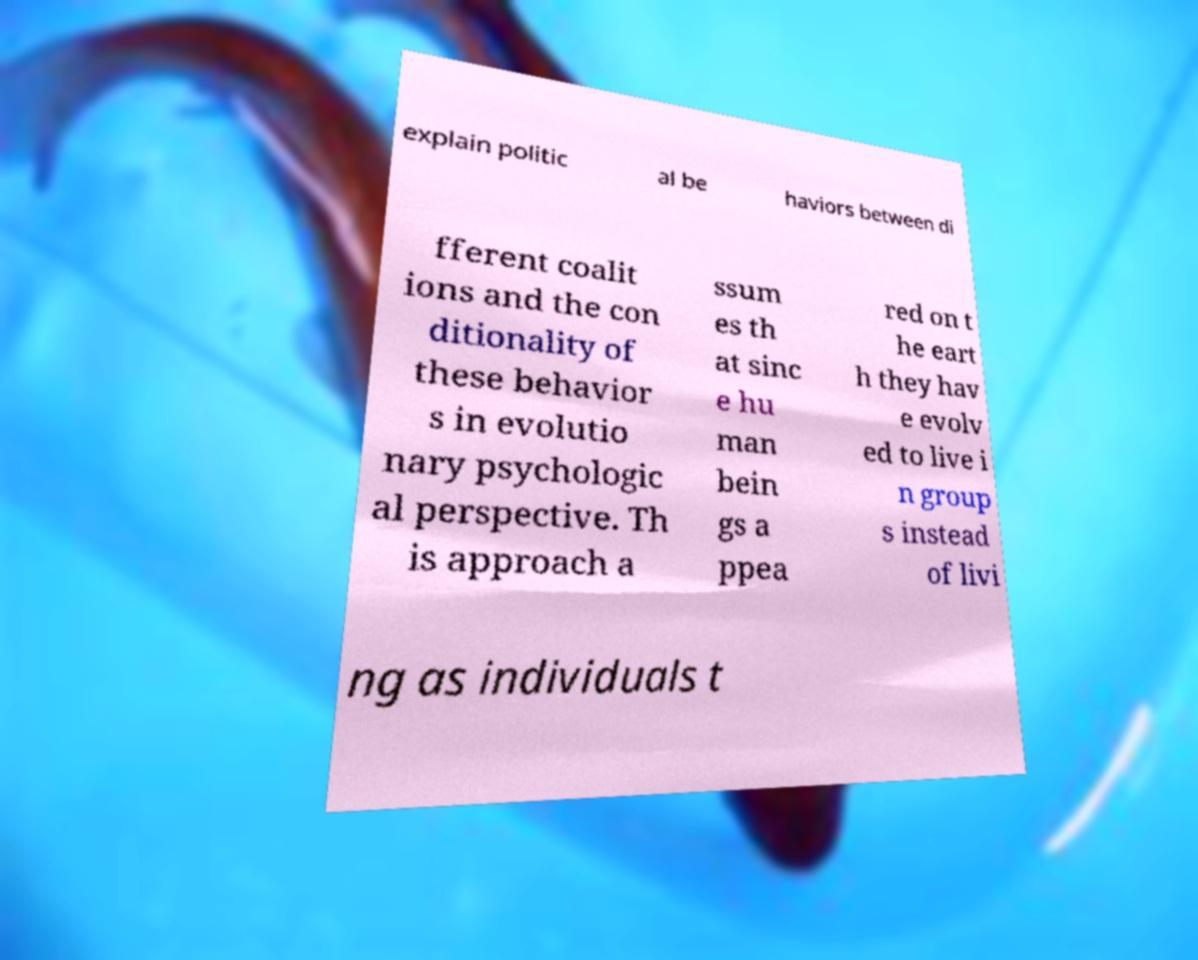Please identify and transcribe the text found in this image. explain politic al be haviors between di fferent coalit ions and the con ditionality of these behavior s in evolutio nary psychologic al perspective. Th is approach a ssum es th at sinc e hu man bein gs a ppea red on t he eart h they hav e evolv ed to live i n group s instead of livi ng as individuals t 